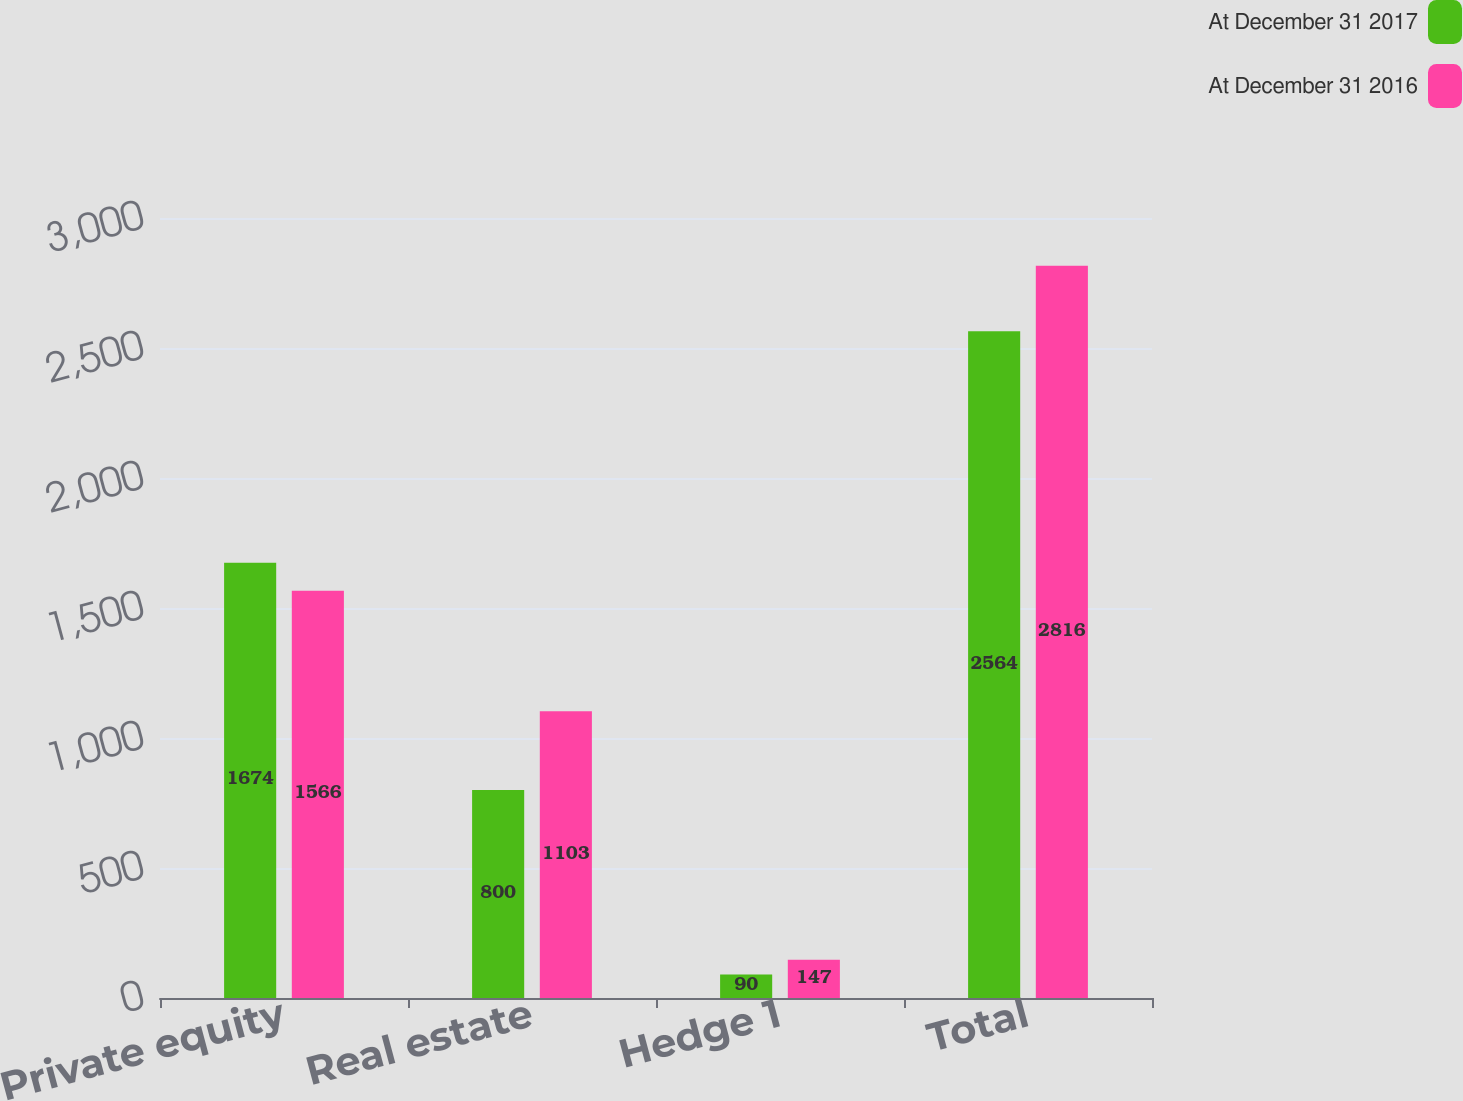Convert chart. <chart><loc_0><loc_0><loc_500><loc_500><stacked_bar_chart><ecel><fcel>Private equity<fcel>Real estate<fcel>Hedge 1<fcel>Total<nl><fcel>At December 31 2017<fcel>1674<fcel>800<fcel>90<fcel>2564<nl><fcel>At December 31 2016<fcel>1566<fcel>1103<fcel>147<fcel>2816<nl></chart> 